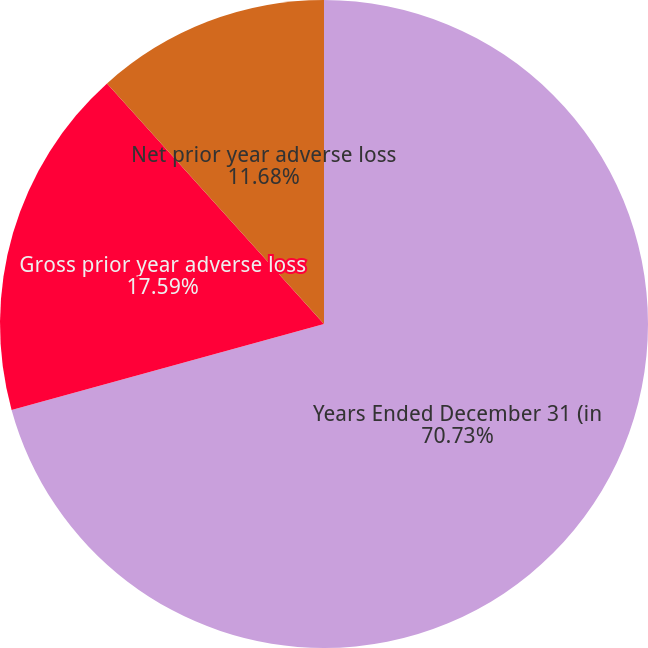Convert chart. <chart><loc_0><loc_0><loc_500><loc_500><pie_chart><fcel>Years Ended December 31 (in<fcel>Gross prior year adverse loss<fcel>Net prior year adverse loss<nl><fcel>70.73%<fcel>17.59%<fcel>11.68%<nl></chart> 